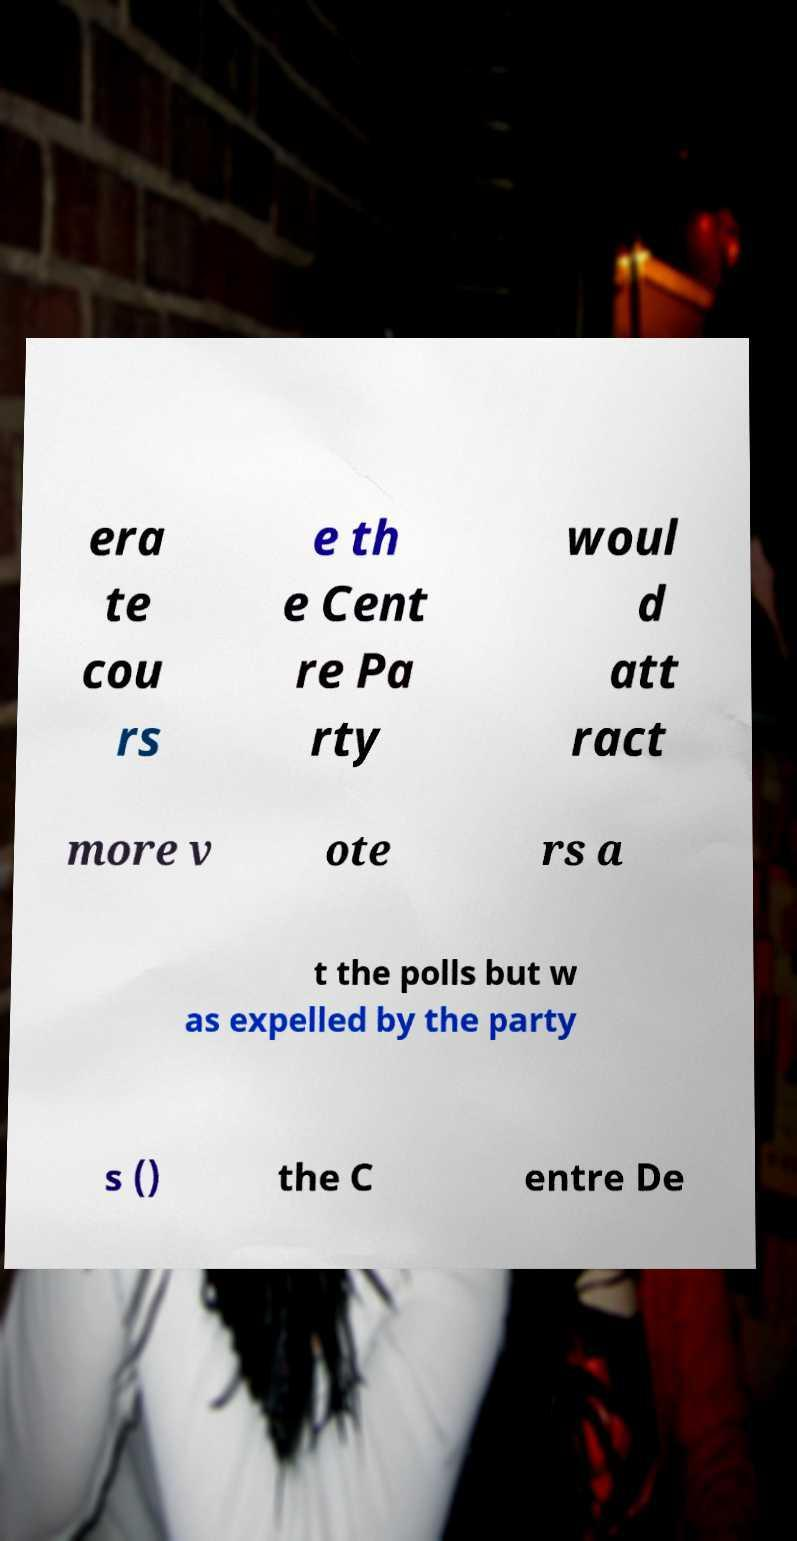What messages or text are displayed in this image? I need them in a readable, typed format. era te cou rs e th e Cent re Pa rty woul d att ract more v ote rs a t the polls but w as expelled by the party s () the C entre De 